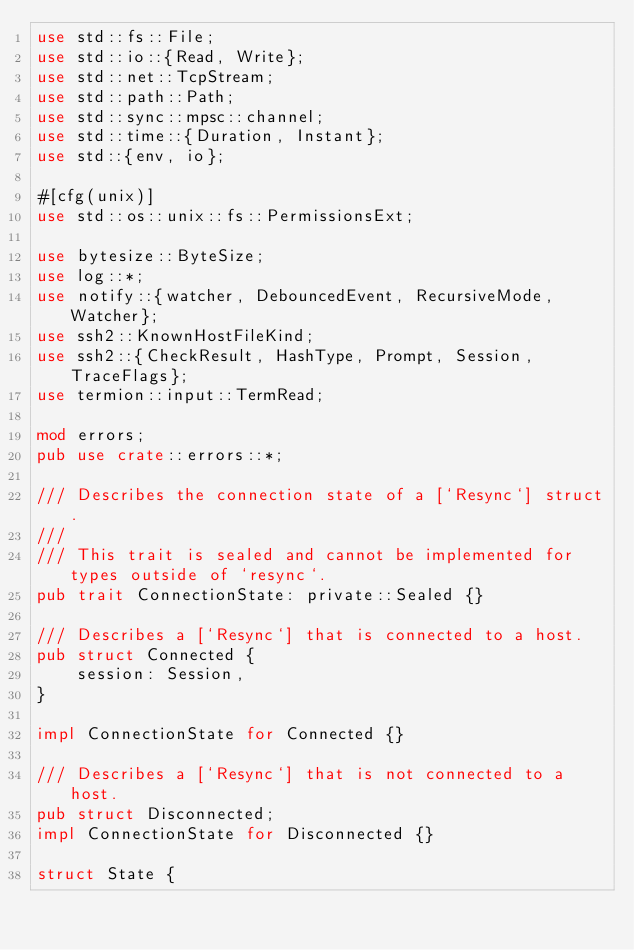<code> <loc_0><loc_0><loc_500><loc_500><_Rust_>use std::fs::File;
use std::io::{Read, Write};
use std::net::TcpStream;
use std::path::Path;
use std::sync::mpsc::channel;
use std::time::{Duration, Instant};
use std::{env, io};

#[cfg(unix)]
use std::os::unix::fs::PermissionsExt;

use bytesize::ByteSize;
use log::*;
use notify::{watcher, DebouncedEvent, RecursiveMode, Watcher};
use ssh2::KnownHostFileKind;
use ssh2::{CheckResult, HashType, Prompt, Session, TraceFlags};
use termion::input::TermRead;

mod errors;
pub use crate::errors::*;

/// Describes the connection state of a [`Resync`] struct.
///
/// This trait is sealed and cannot be implemented for types outside of `resync`.
pub trait ConnectionState: private::Sealed {}

/// Describes a [`Resync`] that is connected to a host.
pub struct Connected {
    session: Session,
}

impl ConnectionState for Connected {}

/// Describes a [`Resync`] that is not connected to a host.
pub struct Disconnected;
impl ConnectionState for Disconnected {}

struct State {</code> 